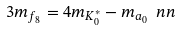Convert formula to latex. <formula><loc_0><loc_0><loc_500><loc_500>3 m _ { f _ { 8 } } = 4 m _ { K _ { 0 } ^ { * } } - m _ { a _ { 0 } } \ n n</formula> 